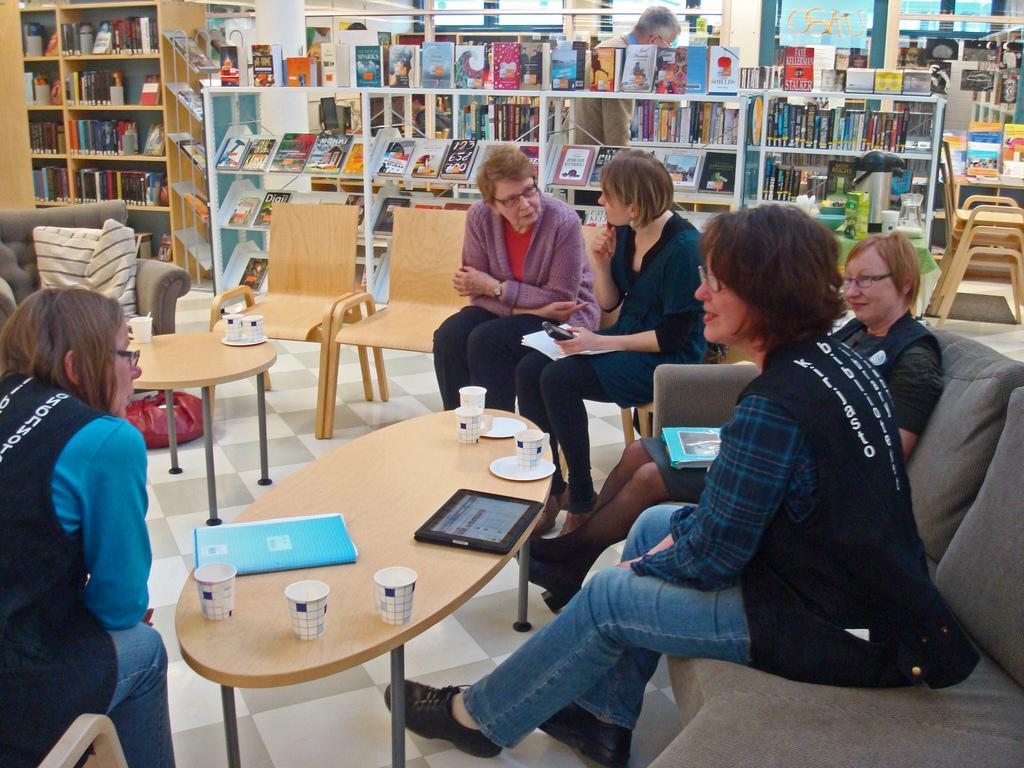What are the people in the image doing? The people are sitting at a table in the image. What can be seen in front of the people at the table? The people have coffee glasses in front of them. What is visible in the background of the image? There are many books in the background of the image. What type of punishment is being discussed by the people at the table in the image? There is no indication in the image that the people are discussing any type of punishment. 